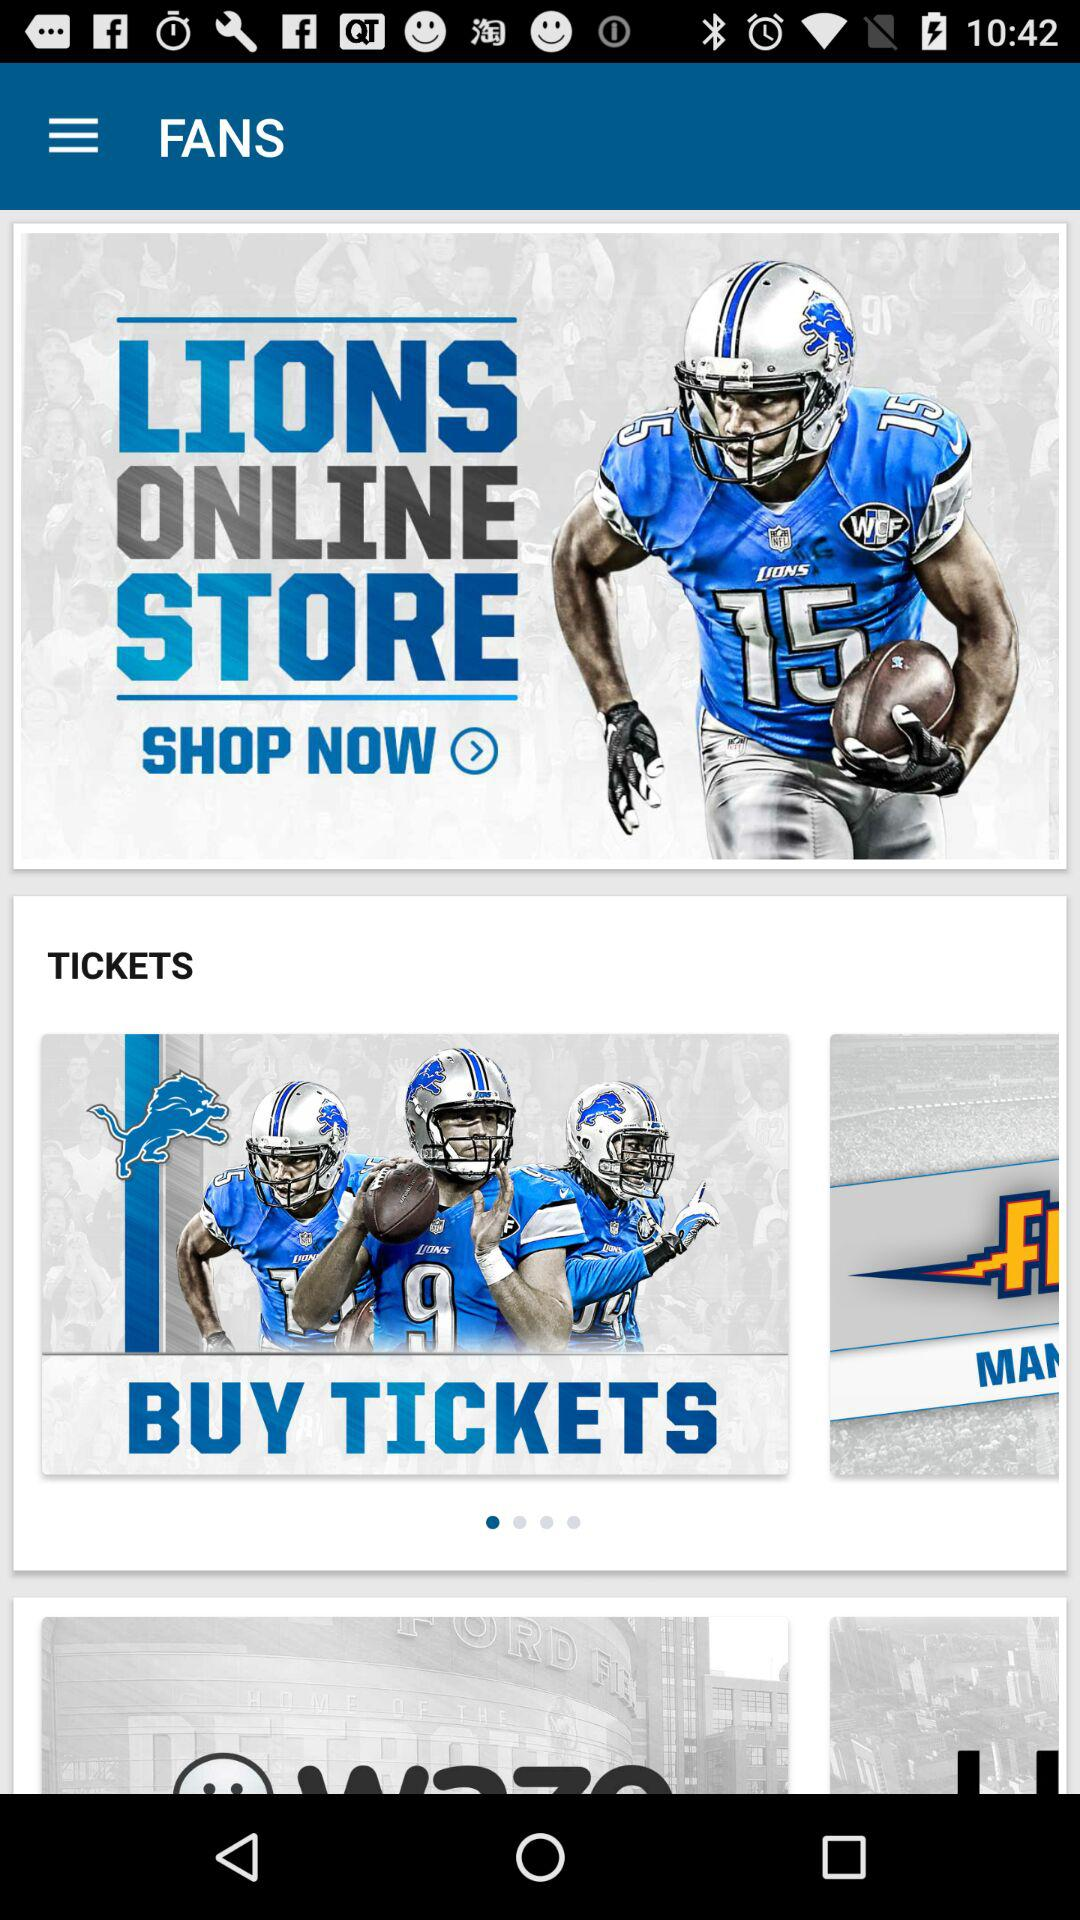How many items are in the 'Fans' section?
Answer the question using a single word or phrase. 3 